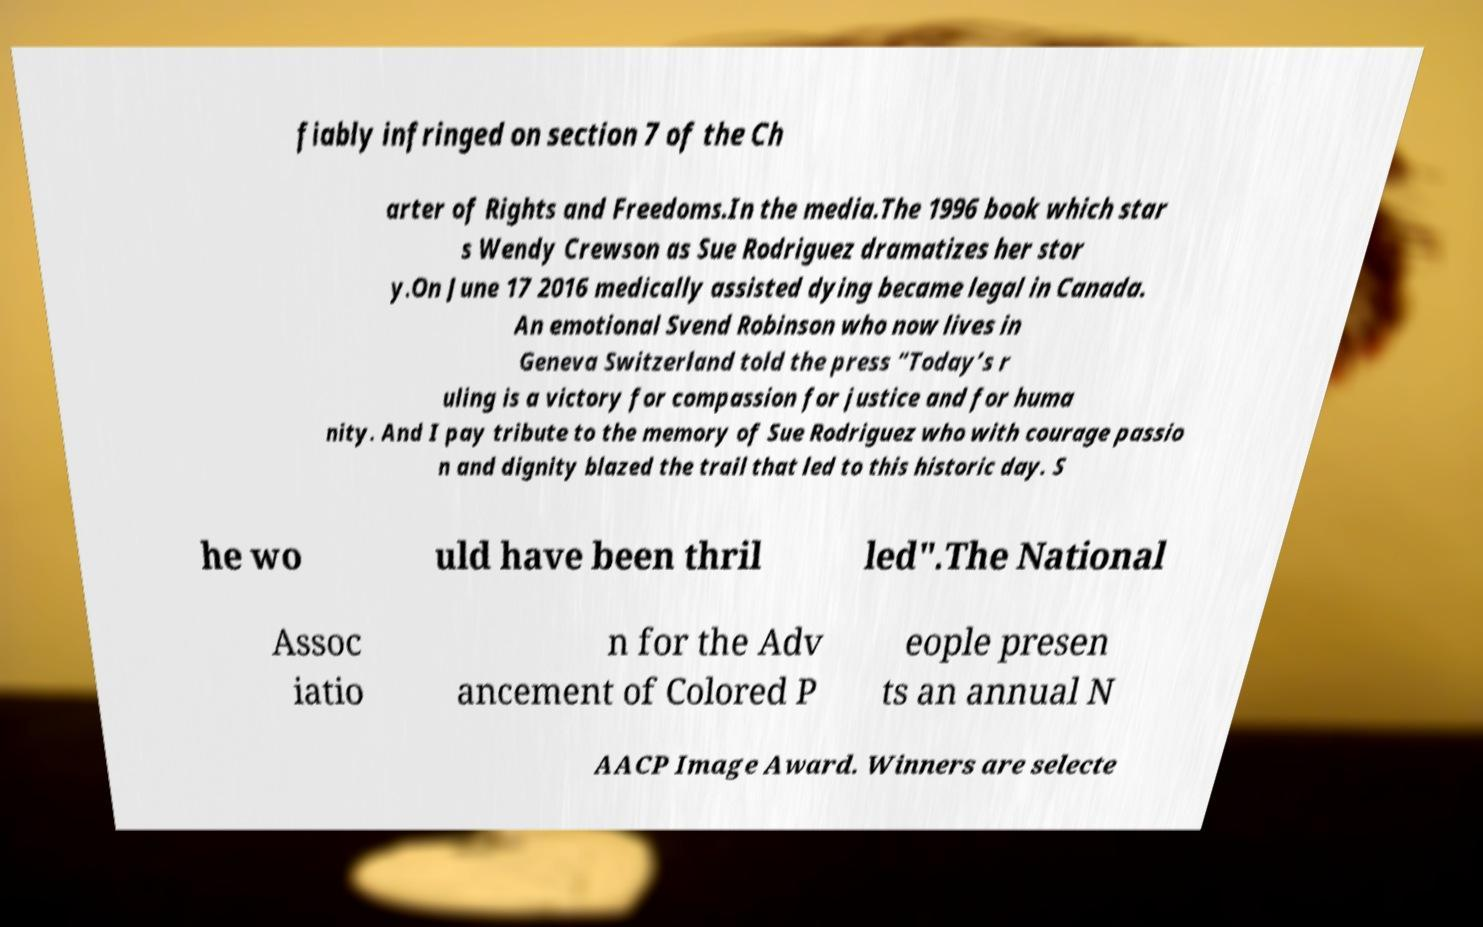Can you accurately transcribe the text from the provided image for me? fiably infringed on section 7 of the Ch arter of Rights and Freedoms.In the media.The 1996 book which star s Wendy Crewson as Sue Rodriguez dramatizes her stor y.On June 17 2016 medically assisted dying became legal in Canada. An emotional Svend Robinson who now lives in Geneva Switzerland told the press “Today’s r uling is a victory for compassion for justice and for huma nity. And I pay tribute to the memory of Sue Rodriguez who with courage passio n and dignity blazed the trail that led to this historic day. S he wo uld have been thril led".The National Assoc iatio n for the Adv ancement of Colored P eople presen ts an annual N AACP Image Award. Winners are selecte 